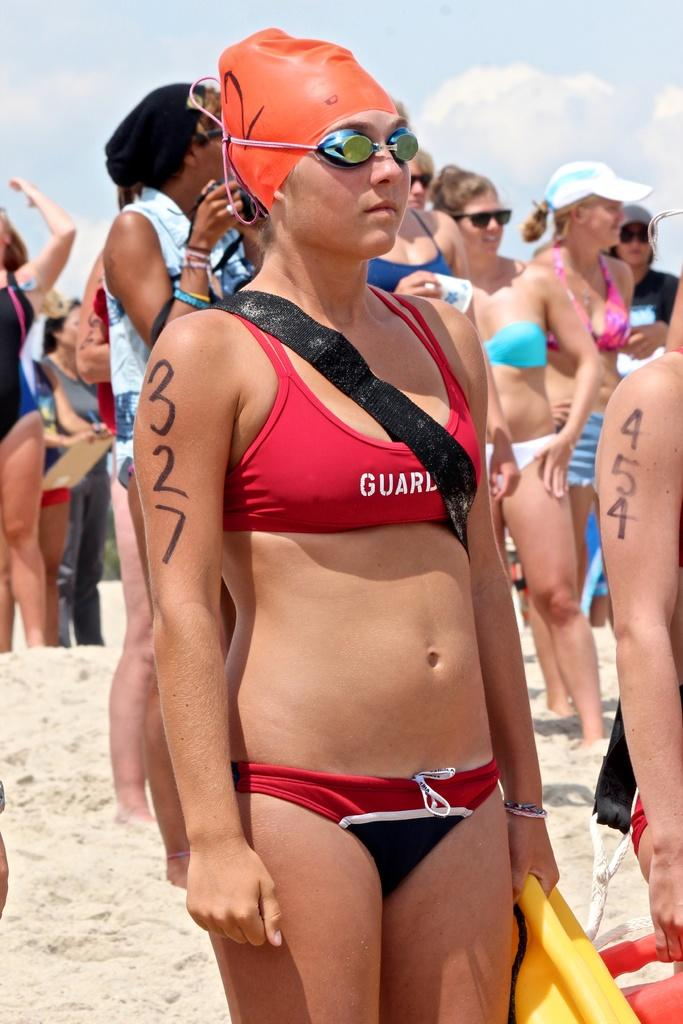Provide a one-sentence caption for the provided image. Swimmer 327 is relaxing on the beach before her swim race. 